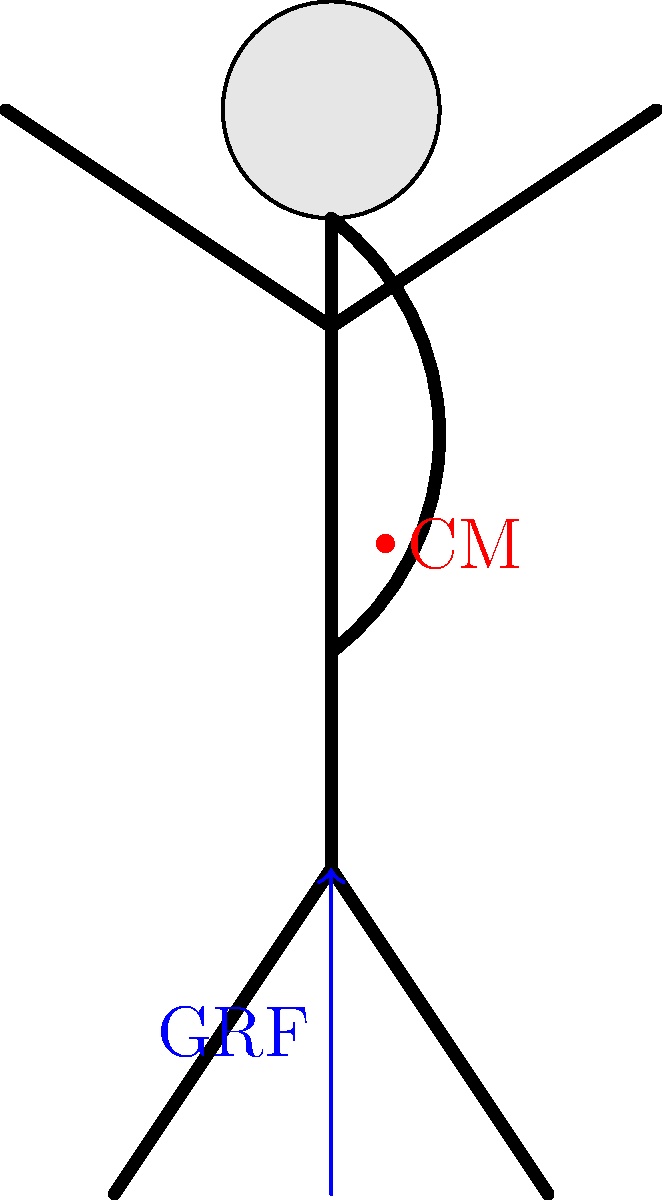In a classic comedic gesture, you're performing an exaggerated lean-back pose. Considering the body's center of mass (CM) and ground reaction force (GRF), explain why this posture is challenging to maintain and how it contributes to the comedic effect. To understand the biomechanics of this comedic gesture, let's break it down step-by-step:

1. Normal posture: In a typical standing position, the body's center of mass (CM) is usually aligned vertically with the base of support, and the ground reaction force (GRF) passes through the CM.

2. Exaggerated lean-back: In this pose, the upper body is tilted backwards, shifting the CM posterior to its normal position.

3. Center of Mass (CM) shift: The red dot in the diagram represents the new position of the CM, which is now behind the feet.

4. Ground Reaction Force (GRF): The blue arrow represents the GRF, which always acts vertically upward from the ground at the point of contact (in this case, the feet).

5. Misalignment: The CM is no longer aligned with the GRF, creating an unstable position.

6. Torque: This misalignment creates a torque around the ankle joint, tending to rotate the body backwards.

7. Muscle activation: To maintain this pose, the anterior muscles (especially in the legs and core) must work harder to counteract this torque.

8. Balance challenge: This posture is difficult to maintain due to the constant muscular effort required and the small base of support (feet).

9. Comedic effect: The exaggerated nature of the pose, combined with the visible effort to maintain balance, creates a visually amusing spectacle for the audience.

10. Potential for "slapstick": The unstable nature of the pose sets up the potential for a comedic fall, which audiences anticipate and find entertaining.

This biomechanical analysis explains why the pose is both challenging to maintain and effective as a comedic gesture.
Answer: Misaligned CM and GRF create instability and visible effort, enhancing comedic effect. 